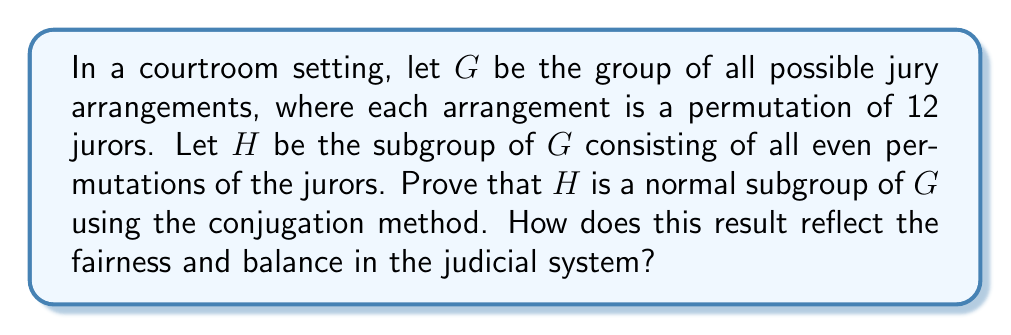What is the answer to this math problem? To prove that $H$ is a normal subgroup of $G$ using conjugation, we need to show that for all $g \in G$ and $h \in H$, $ghg^{-1} \in H$. This means that conjugating any element of $H$ by any element of $G$ results in an element that is still in $H$.

Step 1: Understand the groups
$G$ is the symmetric group $S_{12}$, which contains all permutations of 12 elements.
$H$ is the alternating group $A_{12}$, which contains all even permutations of 12 elements.

Step 2: Consider conjugation
Let $g \in G$ and $h \in H$. We need to prove that $ghg^{-1} \in H$.

Step 3: Analyze the parity of permutations
- $g$ can be either an even or odd permutation.
- $h$ is always an even permutation (since $h \in H = A_{12}$).
- $g^{-1}$ has the same parity as $g$.

Step 4: Use the properties of permutation composition
- The composition of two even permutations is even.
- The composition of an even and an odd permutation is odd.
- The composition of two odd permutations is even.

Step 5: Consider the two cases for $g$

Case 1: If $g$ is even
$ghg^{-1}$ = (even)(even)(even) = even

Case 2: If $g$ is odd
$ghg^{-1}$ = (odd)(even)(odd) = even

In both cases, $ghg^{-1}$ is an even permutation, which means it belongs to $H$.

Step 6: Conclusion
Since $ghg^{-1} \in H$ for all $g \in G$ and $h \in H$, we have proven that $H$ is a normal subgroup of $G$ using the conjugation method.

Reflection on fairness: This result shows that the property of being an even permutation is preserved under conjugation by any permutation. In the context of jury arrangements, it suggests that the fundamental structure of fair jury selection (represented by even permutations) remains intact regardless of how the overall pool of jurors is rearranged. This mathematical property aligns with the principle of maintaining fairness and balance in the judicial system, regardless of external influences on jury selection.
Answer: $H$ is a normal subgroup of $G$ because for all $g \in G$ and $h \in H$, $ghg^{-1} \in H$. This is proven by showing that the conjugate $ghg^{-1}$ is always an even permutation, regardless of whether $g$ is even or odd, thus remaining in $H$. 